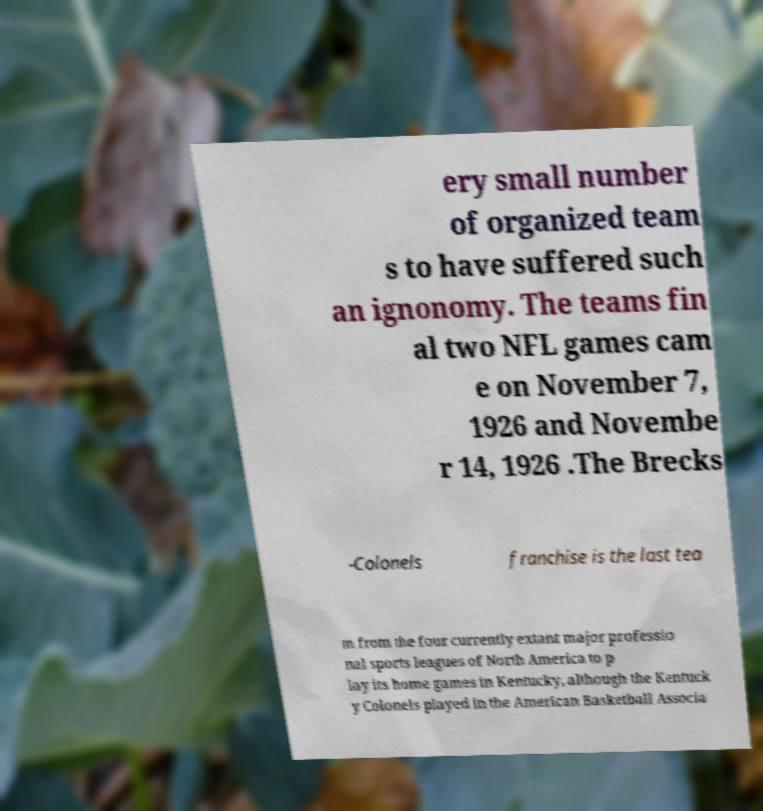I need the written content from this picture converted into text. Can you do that? ery small number of organized team s to have suffered such an ignonomy. The teams fin al two NFL games cam e on November 7, 1926 and Novembe r 14, 1926 .The Brecks -Colonels franchise is the last tea m from the four currently extant major professio nal sports leagues of North America to p lay its home games in Kentucky, although the Kentuck y Colonels played in the American Basketball Associa 